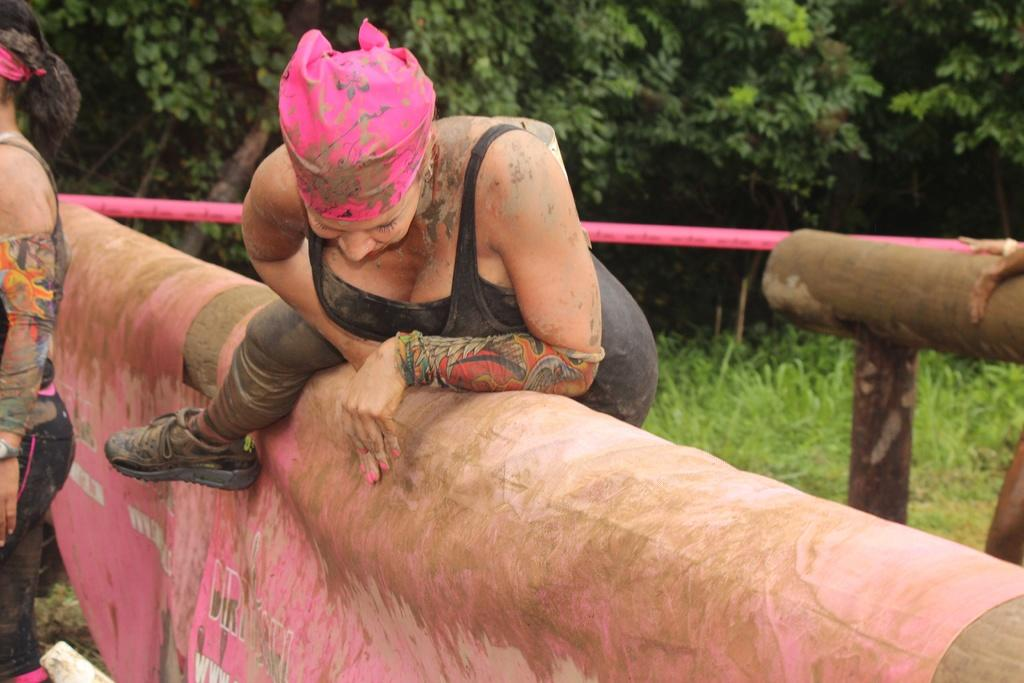How many people are present in the image? There are two people in the image. What type of objects can be seen in the image? There are wooden objects and other objects in the image. What can be seen in the background of the image? There are trees in the background of the image. What type of bubble can be seen in the image? There is no bubble present in the image. How does the string move around in the image? There is no string present in the image. 